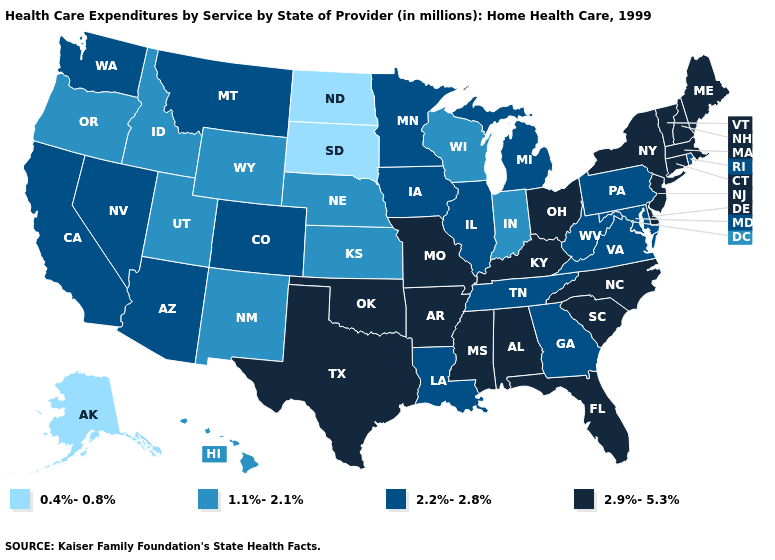What is the value of Wyoming?
Keep it brief. 1.1%-2.1%. What is the value of Louisiana?
Quick response, please. 2.2%-2.8%. Does Connecticut have the lowest value in the Northeast?
Short answer required. No. Does West Virginia have the lowest value in the South?
Answer briefly. Yes. Among the states that border California , does Arizona have the highest value?
Short answer required. Yes. What is the value of Arizona?
Concise answer only. 2.2%-2.8%. Name the states that have a value in the range 2.9%-5.3%?
Short answer required. Alabama, Arkansas, Connecticut, Delaware, Florida, Kentucky, Maine, Massachusetts, Mississippi, Missouri, New Hampshire, New Jersey, New York, North Carolina, Ohio, Oklahoma, South Carolina, Texas, Vermont. What is the lowest value in the West?
Keep it brief. 0.4%-0.8%. Among the states that border Texas , does Arkansas have the highest value?
Be succinct. Yes. Name the states that have a value in the range 2.9%-5.3%?
Quick response, please. Alabama, Arkansas, Connecticut, Delaware, Florida, Kentucky, Maine, Massachusetts, Mississippi, Missouri, New Hampshire, New Jersey, New York, North Carolina, Ohio, Oklahoma, South Carolina, Texas, Vermont. What is the value of Nebraska?
Concise answer only. 1.1%-2.1%. Name the states that have a value in the range 2.9%-5.3%?
Concise answer only. Alabama, Arkansas, Connecticut, Delaware, Florida, Kentucky, Maine, Massachusetts, Mississippi, Missouri, New Hampshire, New Jersey, New York, North Carolina, Ohio, Oklahoma, South Carolina, Texas, Vermont. Is the legend a continuous bar?
Concise answer only. No. Is the legend a continuous bar?
Short answer required. No. Name the states that have a value in the range 2.9%-5.3%?
Quick response, please. Alabama, Arkansas, Connecticut, Delaware, Florida, Kentucky, Maine, Massachusetts, Mississippi, Missouri, New Hampshire, New Jersey, New York, North Carolina, Ohio, Oklahoma, South Carolina, Texas, Vermont. 